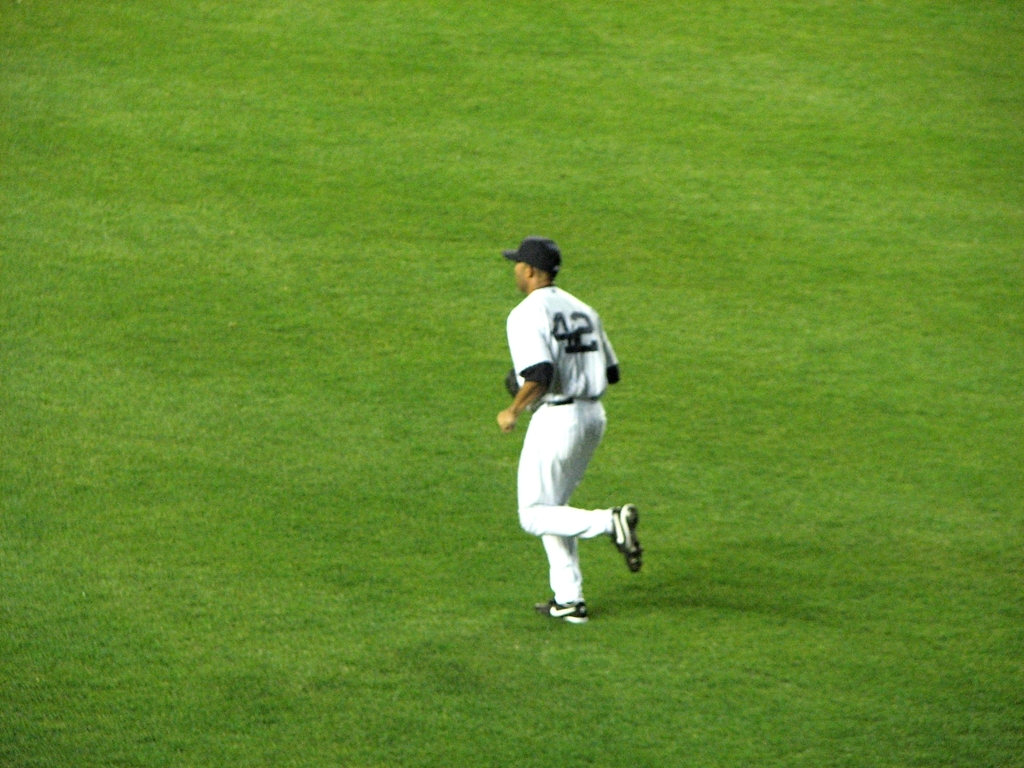Does the image indicate whether the field is for professional or amateur use? The presence of well-defined player number '42' on the uniform and the quality of the field suggest that this is a professional setting, as such numbers and maintenance levels are typical of professional sports teams. Can you tell if the game is currently in play? The player is seen jogging alone on the field, which could indicate that the game is not actively in play at the moment; it might be a break, warm-up, or cool-down period. 